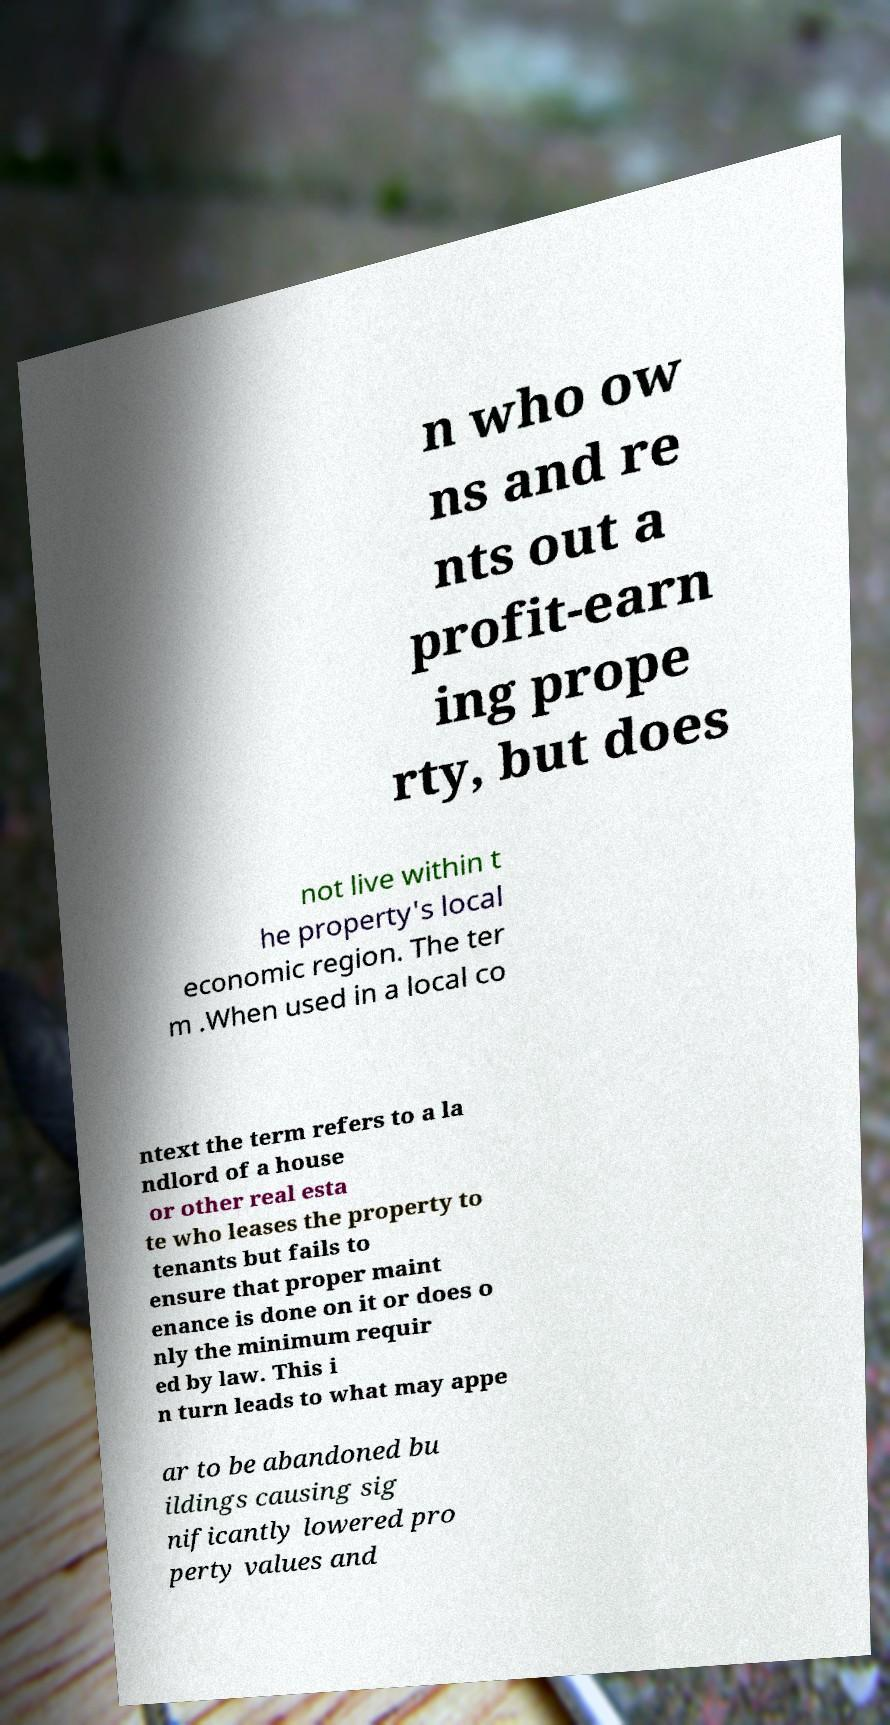I need the written content from this picture converted into text. Can you do that? n who ow ns and re nts out a profit-earn ing prope rty, but does not live within t he property's local economic region. The ter m .When used in a local co ntext the term refers to a la ndlord of a house or other real esta te who leases the property to tenants but fails to ensure that proper maint enance is done on it or does o nly the minimum requir ed by law. This i n turn leads to what may appe ar to be abandoned bu ildings causing sig nificantly lowered pro perty values and 